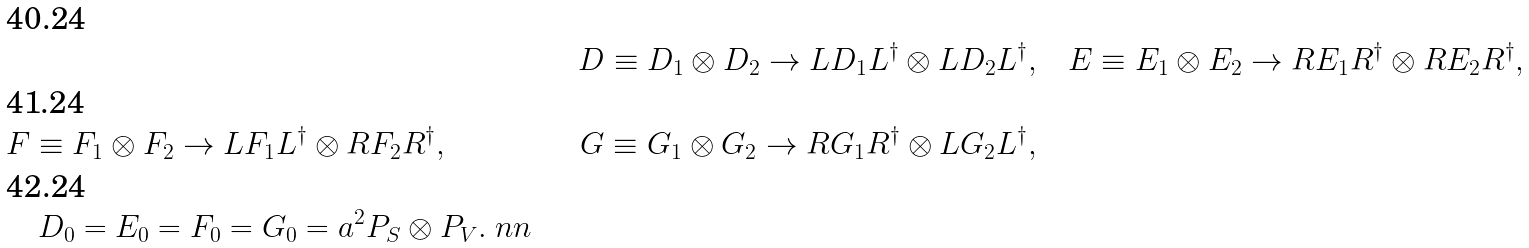Convert formula to latex. <formula><loc_0><loc_0><loc_500><loc_500>& \quad & D \equiv D _ { 1 } \otimes D _ { 2 } \to L D _ { 1 } L ^ { \dag } \otimes L D _ { 2 } L ^ { \dag } , & \quad E \equiv E _ { 1 } \otimes E _ { 2 } \to R E _ { 1 } R ^ { \dag } \otimes R E _ { 2 } R ^ { \dag } , \\ & F \equiv F _ { 1 } \otimes F _ { 2 } \to L F _ { 1 } L ^ { \dag } \otimes R F _ { 2 } R ^ { \dag } , & \quad G \equiv G _ { 1 } \otimes G _ { 2 } \to R G _ { 1 } R ^ { \dag } \otimes L G _ { 2 } L ^ { \dag } , \\ & \quad D _ { 0 } = E _ { 0 } = F _ { 0 } = G _ { 0 } = a ^ { 2 } P _ { S } \otimes P _ { V } . \ n n</formula> 